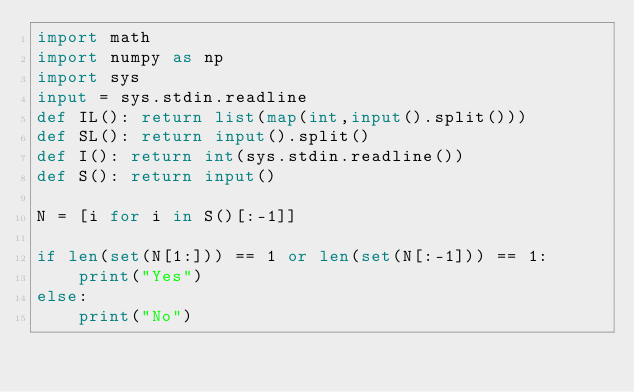Convert code to text. <code><loc_0><loc_0><loc_500><loc_500><_Python_>import math
import numpy as np
import sys
input = sys.stdin.readline
def IL(): return list(map(int,input().split()))
def SL(): return input().split()
def I(): return int(sys.stdin.readline())
def S(): return input()

N = [i for i in S()[:-1]]

if len(set(N[1:])) == 1 or len(set(N[:-1])) == 1:
	print("Yes")
else:
	print("No")</code> 